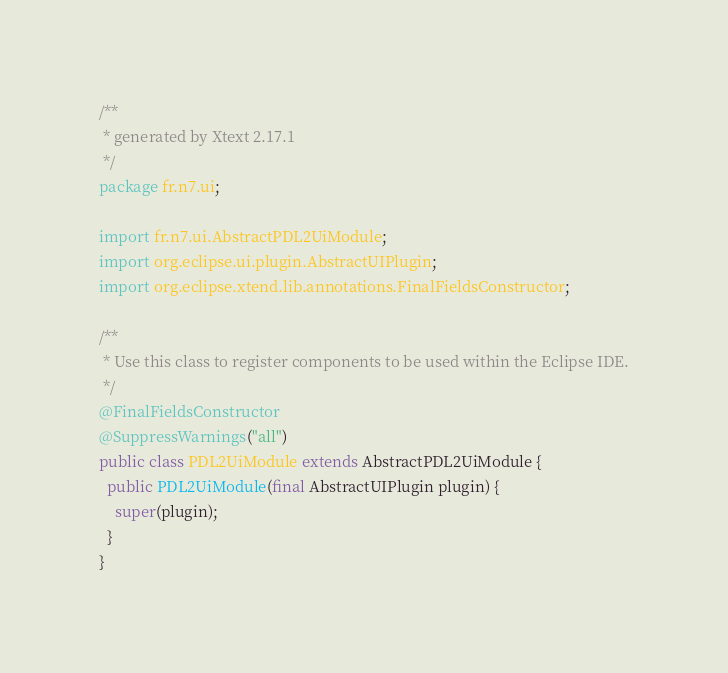<code> <loc_0><loc_0><loc_500><loc_500><_Java_>/**
 * generated by Xtext 2.17.1
 */
package fr.n7.ui;

import fr.n7.ui.AbstractPDL2UiModule;
import org.eclipse.ui.plugin.AbstractUIPlugin;
import org.eclipse.xtend.lib.annotations.FinalFieldsConstructor;

/**
 * Use this class to register components to be used within the Eclipse IDE.
 */
@FinalFieldsConstructor
@SuppressWarnings("all")
public class PDL2UiModule extends AbstractPDL2UiModule {
  public PDL2UiModule(final AbstractUIPlugin plugin) {
    super(plugin);
  }
}
</code> 